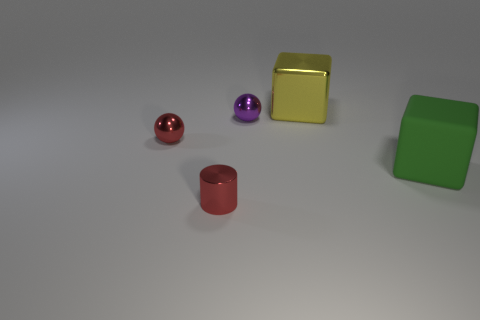How many small red shiny things are there?
Give a very brief answer. 2. Do the metal cylinder and the cube in front of the purple shiny object have the same color?
Ensure brevity in your answer.  No. Are there more red shiny balls than large cyan shiny cubes?
Keep it short and to the point. Yes. Is there anything else of the same color as the matte cube?
Offer a terse response. No. How many other things are the same size as the metal cylinder?
Your response must be concise. 2. What material is the large object that is in front of the red thing behind the red metal thing that is in front of the red metallic ball?
Give a very brief answer. Rubber. Does the small purple ball have the same material as the tiny red object in front of the green rubber cube?
Offer a very short reply. Yes. Are there fewer tiny purple objects on the right side of the large yellow object than red shiny balls to the left of the small red sphere?
Your answer should be very brief. No. What number of small red things have the same material as the small cylinder?
Offer a very short reply. 1. There is a big object that is behind the large cube in front of the big yellow block; is there a green cube that is left of it?
Your answer should be compact. No. 